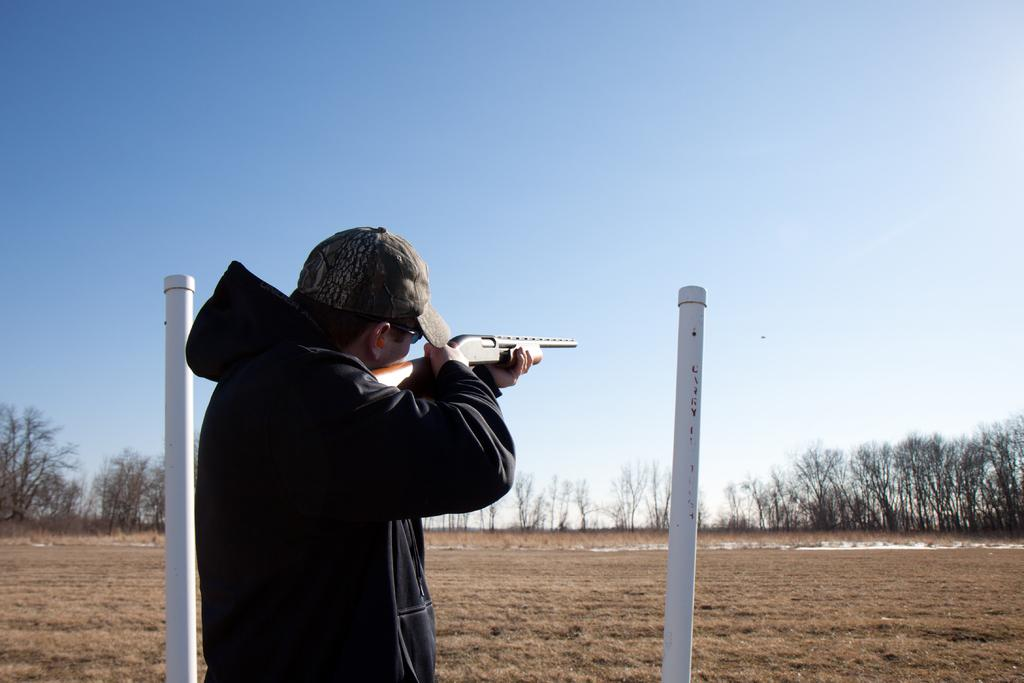What is the main subject of the image? The main subject of the image is a man. What is the man doing in the image? The man is standing on the ground surface and aiming a gun towards the sky. What is the man wearing in the image? The man is wearing a hoodie and a cap. What can be seen in the background of the image? There are trees and the sky visible in the background of the image. What type of reward is the man holding in the image? There is no reward visible in the image; the man is holding a gun. How many friends can be seen with the man in the image? There are no friends present in the image; the man is alone. 